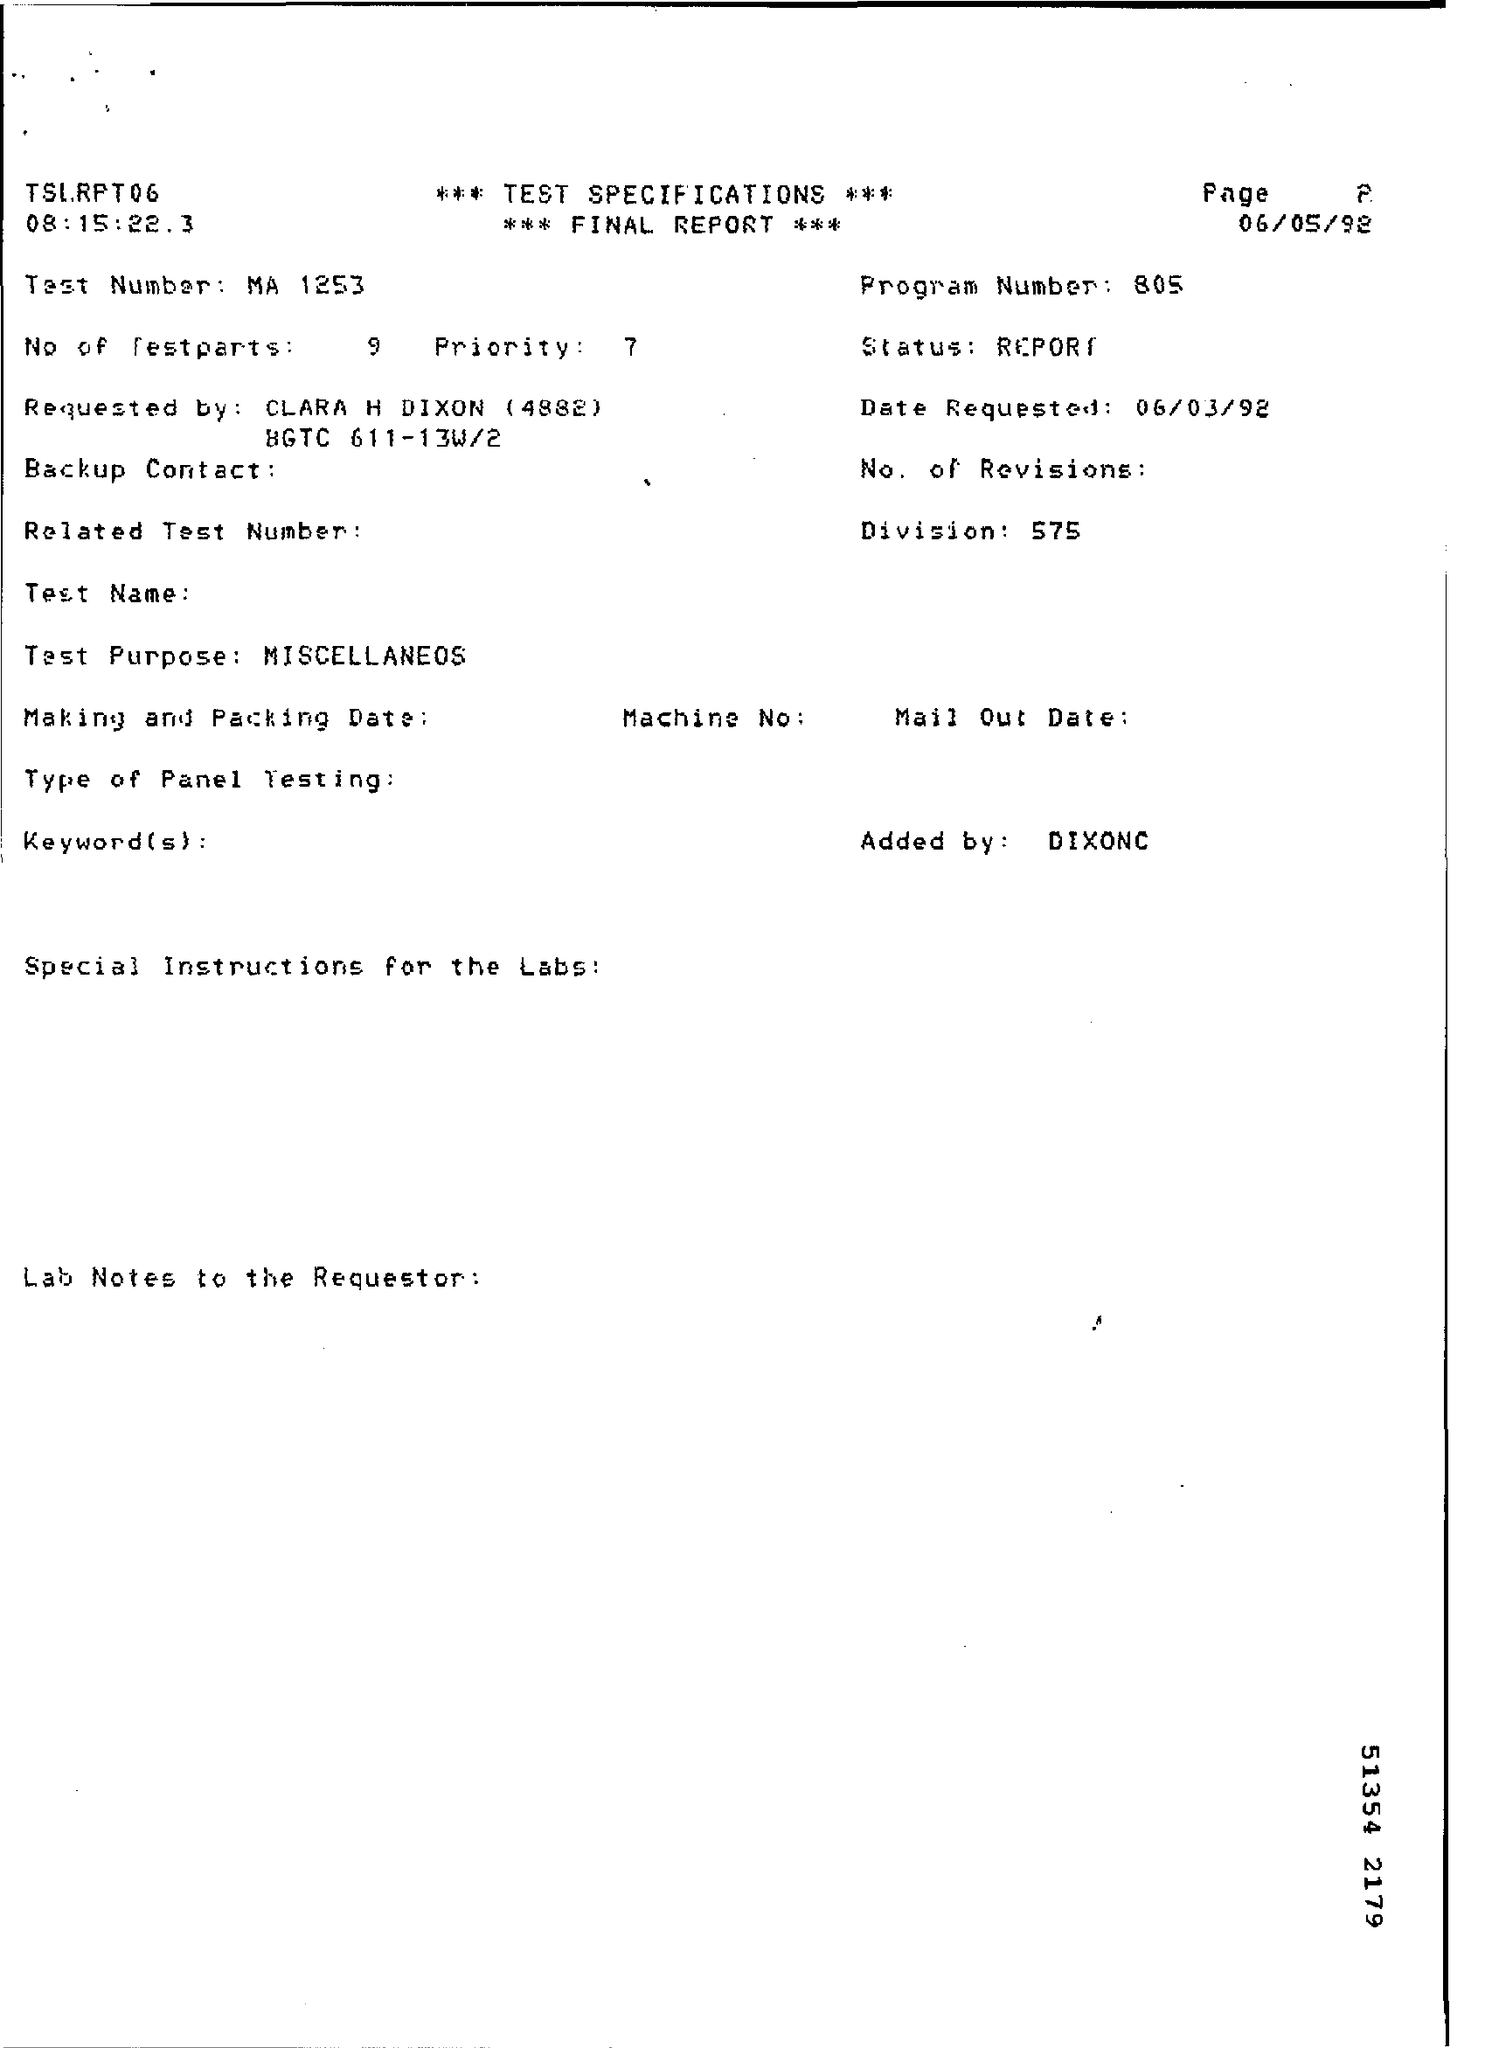List a handful of essential elements in this visual. The program number is 805. The number 575 is the division number. 